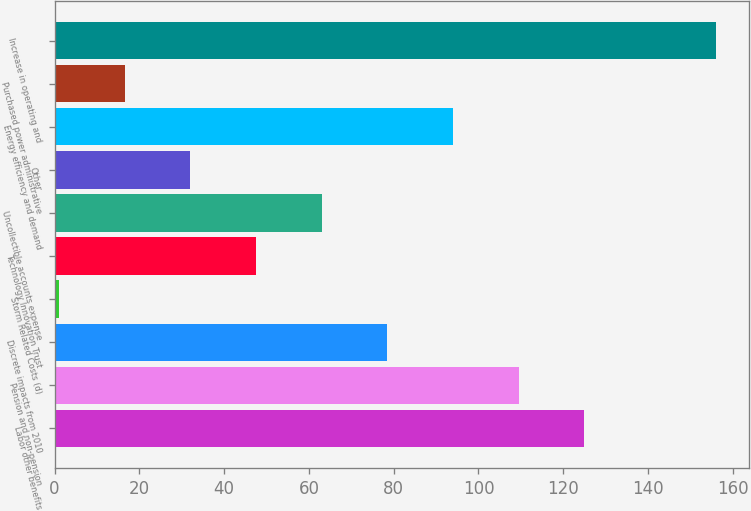Convert chart to OTSL. <chart><loc_0><loc_0><loc_500><loc_500><bar_chart><fcel>Labor other benefits<fcel>Pension and non-pension<fcel>Discrete impacts from 2010<fcel>Storm Related Costs (d)<fcel>Technology Innovation Trust<fcel>Uncollectible accounts expense<fcel>Other<fcel>Energy efficiency and demand<fcel>Purchased power administrative<fcel>Increase in operating and<nl><fcel>125<fcel>109.5<fcel>78.5<fcel>1<fcel>47.5<fcel>63<fcel>32<fcel>94<fcel>16.5<fcel>156<nl></chart> 